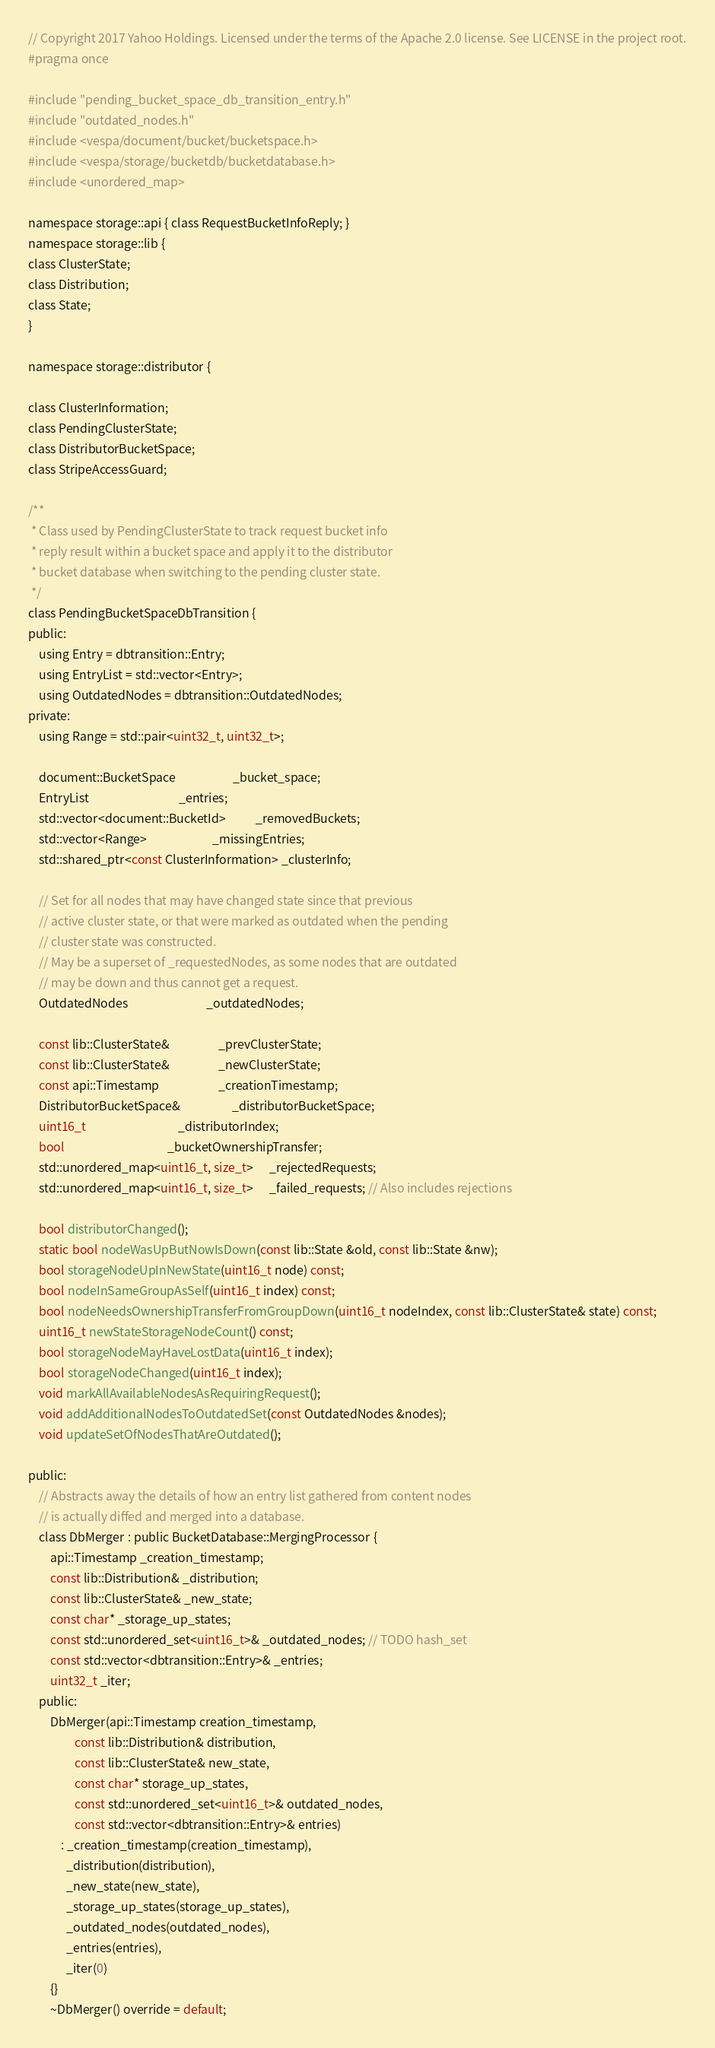Convert code to text. <code><loc_0><loc_0><loc_500><loc_500><_C_>// Copyright 2017 Yahoo Holdings. Licensed under the terms of the Apache 2.0 license. See LICENSE in the project root.
#pragma once

#include "pending_bucket_space_db_transition_entry.h"
#include "outdated_nodes.h"
#include <vespa/document/bucket/bucketspace.h>
#include <vespa/storage/bucketdb/bucketdatabase.h>
#include <unordered_map>

namespace storage::api { class RequestBucketInfoReply; }
namespace storage::lib {
class ClusterState;
class Distribution;
class State;
}

namespace storage::distributor {

class ClusterInformation;
class PendingClusterState;
class DistributorBucketSpace;
class StripeAccessGuard;

/**
 * Class used by PendingClusterState to track request bucket info
 * reply result within a bucket space and apply it to the distributor
 * bucket database when switching to the pending cluster state.
 */
class PendingBucketSpaceDbTransition {
public:
    using Entry = dbtransition::Entry;
    using EntryList = std::vector<Entry>;
    using OutdatedNodes = dbtransition::OutdatedNodes;
private:
    using Range = std::pair<uint32_t, uint32_t>;

    document::BucketSpace                     _bucket_space;
    EntryList                                 _entries;
    std::vector<document::BucketId>           _removedBuckets;
    std::vector<Range>                        _missingEntries;
    std::shared_ptr<const ClusterInformation> _clusterInfo;

    // Set for all nodes that may have changed state since that previous
    // active cluster state, or that were marked as outdated when the pending
    // cluster state was constructed.
    // May be a superset of _requestedNodes, as some nodes that are outdated
    // may be down and thus cannot get a request.
    OutdatedNodes                             _outdatedNodes;

    const lib::ClusterState&                  _prevClusterState;
    const lib::ClusterState&                  _newClusterState;
    const api::Timestamp                      _creationTimestamp;
    DistributorBucketSpace&                   _distributorBucketSpace;
    uint16_t                                  _distributorIndex;
    bool                                      _bucketOwnershipTransfer;
    std::unordered_map<uint16_t, size_t>      _rejectedRequests;
    std::unordered_map<uint16_t, size_t>      _failed_requests; // Also includes rejections

    bool distributorChanged();
    static bool nodeWasUpButNowIsDown(const lib::State &old, const lib::State &nw);
    bool storageNodeUpInNewState(uint16_t node) const;
    bool nodeInSameGroupAsSelf(uint16_t index) const;
    bool nodeNeedsOwnershipTransferFromGroupDown(uint16_t nodeIndex, const lib::ClusterState& state) const;
    uint16_t newStateStorageNodeCount() const;
    bool storageNodeMayHaveLostData(uint16_t index);
    bool storageNodeChanged(uint16_t index);
    void markAllAvailableNodesAsRequiringRequest();
    void addAdditionalNodesToOutdatedSet(const OutdatedNodes &nodes);
    void updateSetOfNodesThatAreOutdated();

public:
    // Abstracts away the details of how an entry list gathered from content nodes
    // is actually diffed and merged into a database.
    class DbMerger : public BucketDatabase::MergingProcessor {
        api::Timestamp _creation_timestamp;
        const lib::Distribution& _distribution;
        const lib::ClusterState& _new_state;
        const char* _storage_up_states;
        const std::unordered_set<uint16_t>& _outdated_nodes; // TODO hash_set
        const std::vector<dbtransition::Entry>& _entries;
        uint32_t _iter;
    public:
        DbMerger(api::Timestamp creation_timestamp,
                 const lib::Distribution& distribution,
                 const lib::ClusterState& new_state,
                 const char* storage_up_states,
                 const std::unordered_set<uint16_t>& outdated_nodes,
                 const std::vector<dbtransition::Entry>& entries)
            : _creation_timestamp(creation_timestamp),
              _distribution(distribution),
              _new_state(new_state),
              _storage_up_states(storage_up_states),
              _outdated_nodes(outdated_nodes),
              _entries(entries),
              _iter(0)
        {}
        ~DbMerger() override = default;
</code> 